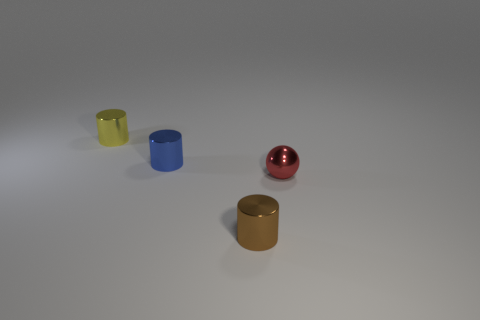There is a metal thing that is in front of the tiny shiny thing on the right side of the brown cylinder; what shape is it?
Ensure brevity in your answer.  Cylinder. What is the shape of the tiny blue thing that is made of the same material as the sphere?
Your response must be concise. Cylinder. There is a metal cylinder that is in front of the tiny blue cylinder; is it the same size as the object that is behind the tiny blue shiny object?
Offer a very short reply. Yes. There is a metal thing that is in front of the metal sphere; what shape is it?
Your answer should be very brief. Cylinder. What color is the shiny ball?
Give a very brief answer. Red. There is a red metal object; does it have the same size as the metallic object that is behind the tiny blue metal cylinder?
Provide a short and direct response. Yes. What number of rubber things are either tiny balls or large objects?
Offer a very short reply. 0. What is the shape of the yellow thing?
Keep it short and to the point. Cylinder. What is the size of the thing to the right of the tiny cylinder in front of the metal object that is on the right side of the brown metal cylinder?
Your response must be concise. Small. What number of other things are the same shape as the brown thing?
Provide a short and direct response. 2. 